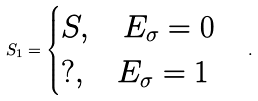<formula> <loc_0><loc_0><loc_500><loc_500>S _ { 1 } = \begin{cases} S , \quad E _ { \sigma } = 0 \\ ? , \quad E _ { \sigma } = 1 \end{cases} .</formula> 